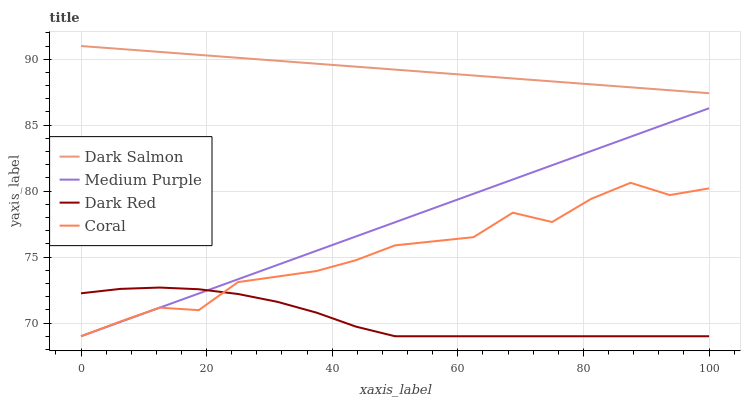Does Coral have the minimum area under the curve?
Answer yes or no. No. Does Coral have the maximum area under the curve?
Answer yes or no. No. Is Dark Red the smoothest?
Answer yes or no. No. Is Dark Red the roughest?
Answer yes or no. No. Does Dark Salmon have the lowest value?
Answer yes or no. No. Does Coral have the highest value?
Answer yes or no. No. Is Medium Purple less than Dark Salmon?
Answer yes or no. Yes. Is Dark Salmon greater than Medium Purple?
Answer yes or no. Yes. Does Medium Purple intersect Dark Salmon?
Answer yes or no. No. 